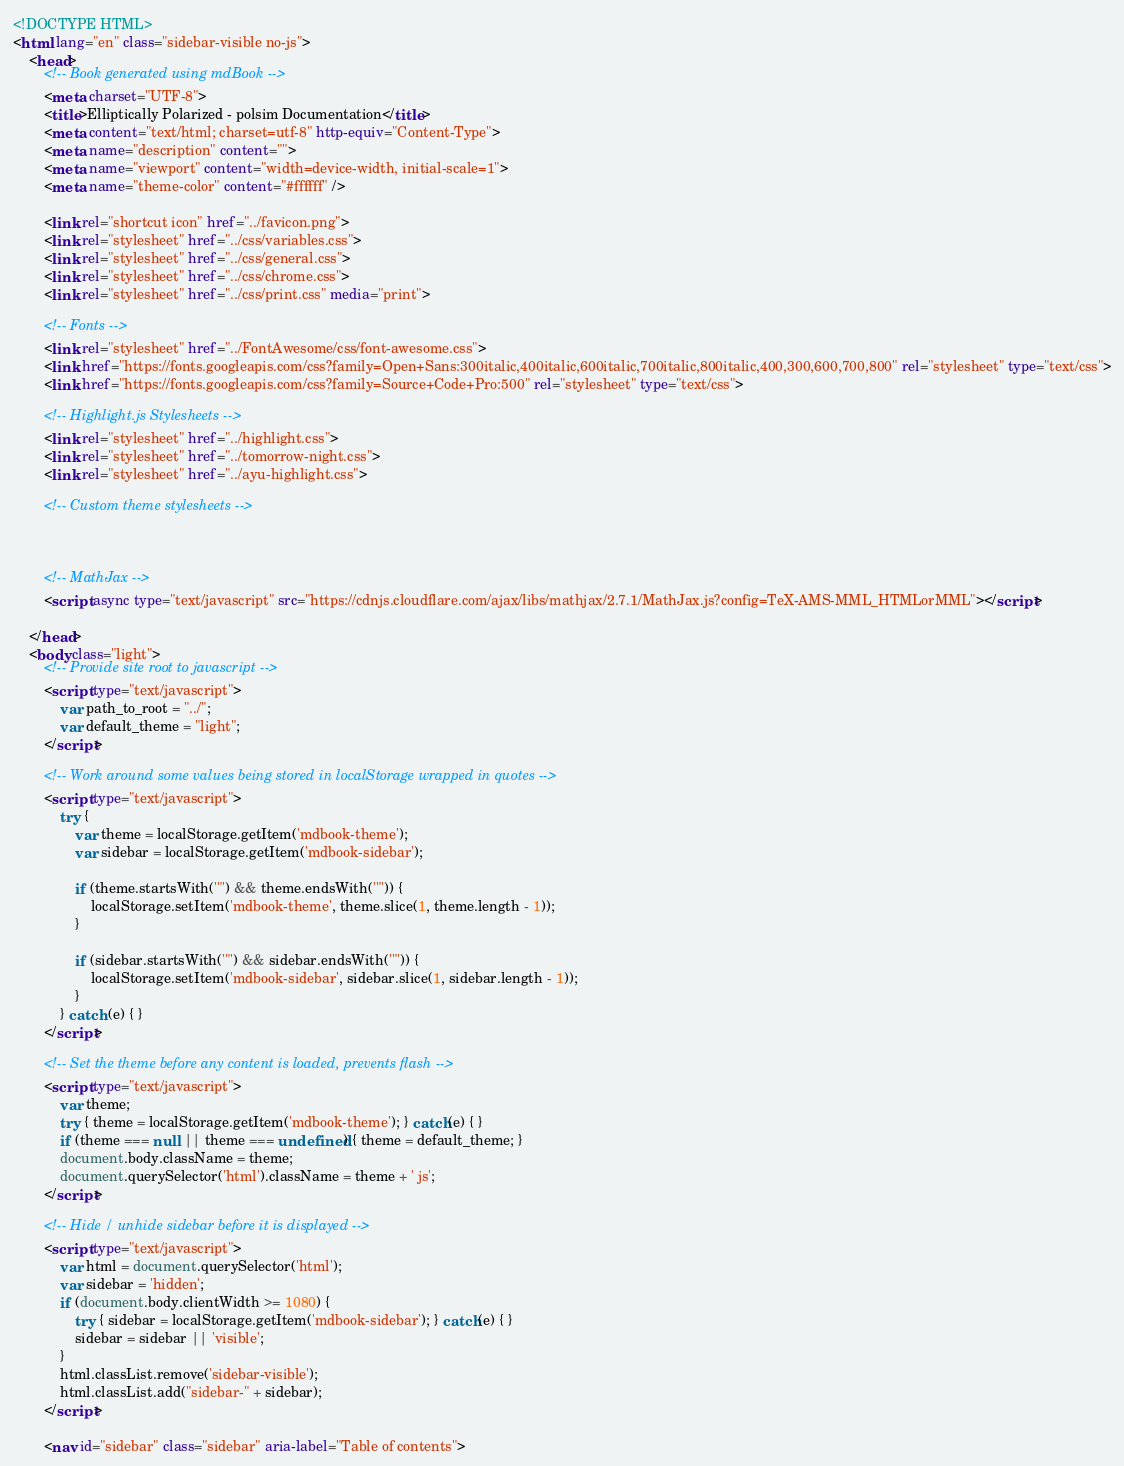Convert code to text. <code><loc_0><loc_0><loc_500><loc_500><_HTML_><!DOCTYPE HTML>
<html lang="en" class="sidebar-visible no-js">
    <head>
        <!-- Book generated using mdBook -->
        <meta charset="UTF-8">
        <title>Elliptically Polarized - polsim Documentation</title>
        <meta content="text/html; charset=utf-8" http-equiv="Content-Type">
        <meta name="description" content="">
        <meta name="viewport" content="width=device-width, initial-scale=1">
        <meta name="theme-color" content="#ffffff" />

        <link rel="shortcut icon" href="../favicon.png">
        <link rel="stylesheet" href="../css/variables.css">
        <link rel="stylesheet" href="../css/general.css">
        <link rel="stylesheet" href="../css/chrome.css">
        <link rel="stylesheet" href="../css/print.css" media="print">

        <!-- Fonts -->
        <link rel="stylesheet" href="../FontAwesome/css/font-awesome.css">
        <link href="https://fonts.googleapis.com/css?family=Open+Sans:300italic,400italic,600italic,700italic,800italic,400,300,600,700,800" rel="stylesheet" type="text/css">
        <link href="https://fonts.googleapis.com/css?family=Source+Code+Pro:500" rel="stylesheet" type="text/css">

        <!-- Highlight.js Stylesheets -->
        <link rel="stylesheet" href="../highlight.css">
        <link rel="stylesheet" href="../tomorrow-night.css">
        <link rel="stylesheet" href="../ayu-highlight.css">

        <!-- Custom theme stylesheets -->
        

        
        <!-- MathJax -->
        <script async type="text/javascript" src="https://cdnjs.cloudflare.com/ajax/libs/mathjax/2.7.1/MathJax.js?config=TeX-AMS-MML_HTMLorMML"></script>
        
    </head>
    <body class="light">
        <!-- Provide site root to javascript -->
        <script type="text/javascript">
            var path_to_root = "../";
            var default_theme = "light";
        </script>

        <!-- Work around some values being stored in localStorage wrapped in quotes -->
        <script type="text/javascript">
            try {
                var theme = localStorage.getItem('mdbook-theme');
                var sidebar = localStorage.getItem('mdbook-sidebar');

                if (theme.startsWith('"') && theme.endsWith('"')) {
                    localStorage.setItem('mdbook-theme', theme.slice(1, theme.length - 1));
                }

                if (sidebar.startsWith('"') && sidebar.endsWith('"')) {
                    localStorage.setItem('mdbook-sidebar', sidebar.slice(1, sidebar.length - 1));
                }
            } catch (e) { }
        </script>

        <!-- Set the theme before any content is loaded, prevents flash -->
        <script type="text/javascript">
            var theme;
            try { theme = localStorage.getItem('mdbook-theme'); } catch(e) { } 
            if (theme === null || theme === undefined) { theme = default_theme; }
            document.body.className = theme;
            document.querySelector('html').className = theme + ' js';
        </script>

        <!-- Hide / unhide sidebar before it is displayed -->
        <script type="text/javascript">
            var html = document.querySelector('html');
            var sidebar = 'hidden';
            if (document.body.clientWidth >= 1080) {
                try { sidebar = localStorage.getItem('mdbook-sidebar'); } catch(e) { }
                sidebar = sidebar || 'visible';
            }
            html.classList.remove('sidebar-visible');
            html.classList.add("sidebar-" + sidebar);
        </script>

        <nav id="sidebar" class="sidebar" aria-label="Table of contents"></code> 